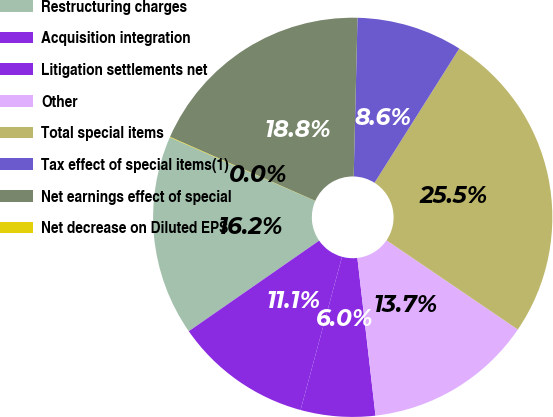Convert chart to OTSL. <chart><loc_0><loc_0><loc_500><loc_500><pie_chart><fcel>Restructuring charges<fcel>Acquisition integration<fcel>Litigation settlements net<fcel>Other<fcel>Total special items<fcel>Tax effect of special items(1)<fcel>Net earnings effect of special<fcel>Net decrease on Diluted EPS<nl><fcel>16.23%<fcel>11.13%<fcel>6.03%<fcel>13.68%<fcel>25.54%<fcel>8.58%<fcel>18.78%<fcel>0.04%<nl></chart> 